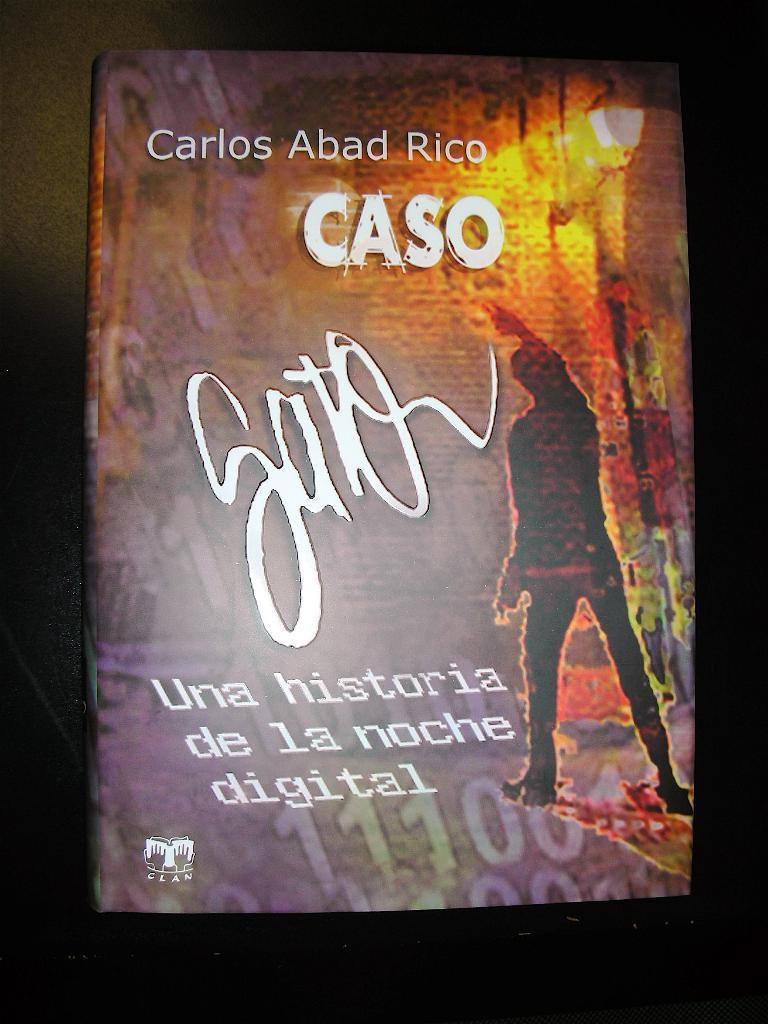<image>
Describe the image concisely. A Spanish language poster which mentions Carlos Abad Rico CASO, hangs on a dark wall. 